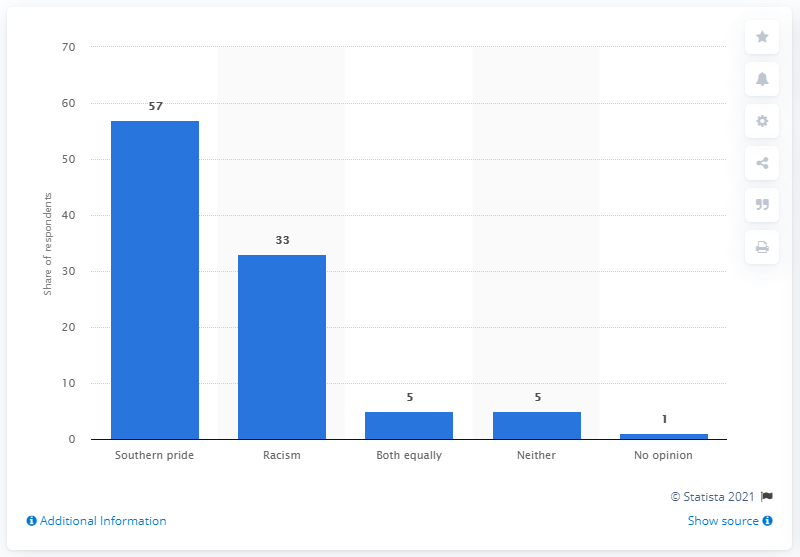Indicate a few pertinent items in this graphic. A total of 33% of respondents stated that they perceive the Confederate flag as a symbol of racism. 